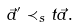<formula> <loc_0><loc_0><loc_500><loc_500>\vec { a } ^ { \prime } \prec _ { s } t \vec { a } .</formula> 